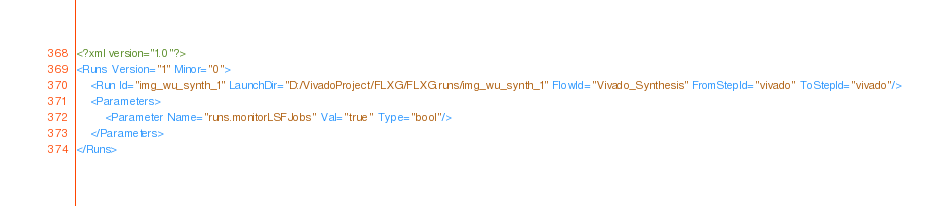Convert code to text. <code><loc_0><loc_0><loc_500><loc_500><_XML_><?xml version="1.0"?>
<Runs Version="1" Minor="0">
	<Run Id="img_wu_synth_1" LaunchDir="D:/VivadoProject/FLXG/FLXG.runs/img_wu_synth_1" FlowId="Vivado_Synthesis" FromStepId="vivado" ToStepId="vivado"/>
	<Parameters>
		<Parameter Name="runs.monitorLSFJobs" Val="true" Type="bool"/>
	</Parameters>
</Runs>

</code> 